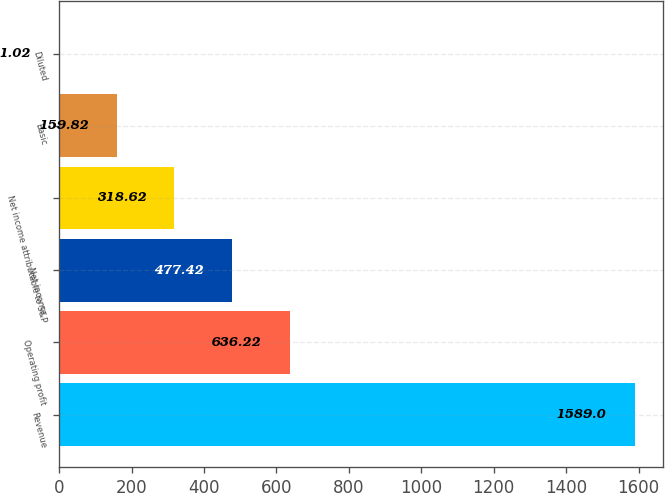<chart> <loc_0><loc_0><loc_500><loc_500><bar_chart><fcel>Revenue<fcel>Operating profit<fcel>Net income<fcel>Net income attributable to S&P<fcel>Basic<fcel>Diluted<nl><fcel>1589<fcel>636.22<fcel>477.42<fcel>318.62<fcel>159.82<fcel>1.02<nl></chart> 